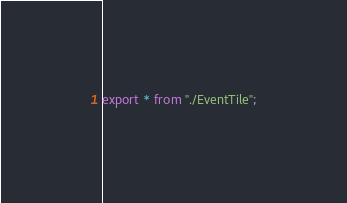<code> <loc_0><loc_0><loc_500><loc_500><_TypeScript_>export * from "./EventTile";
</code> 